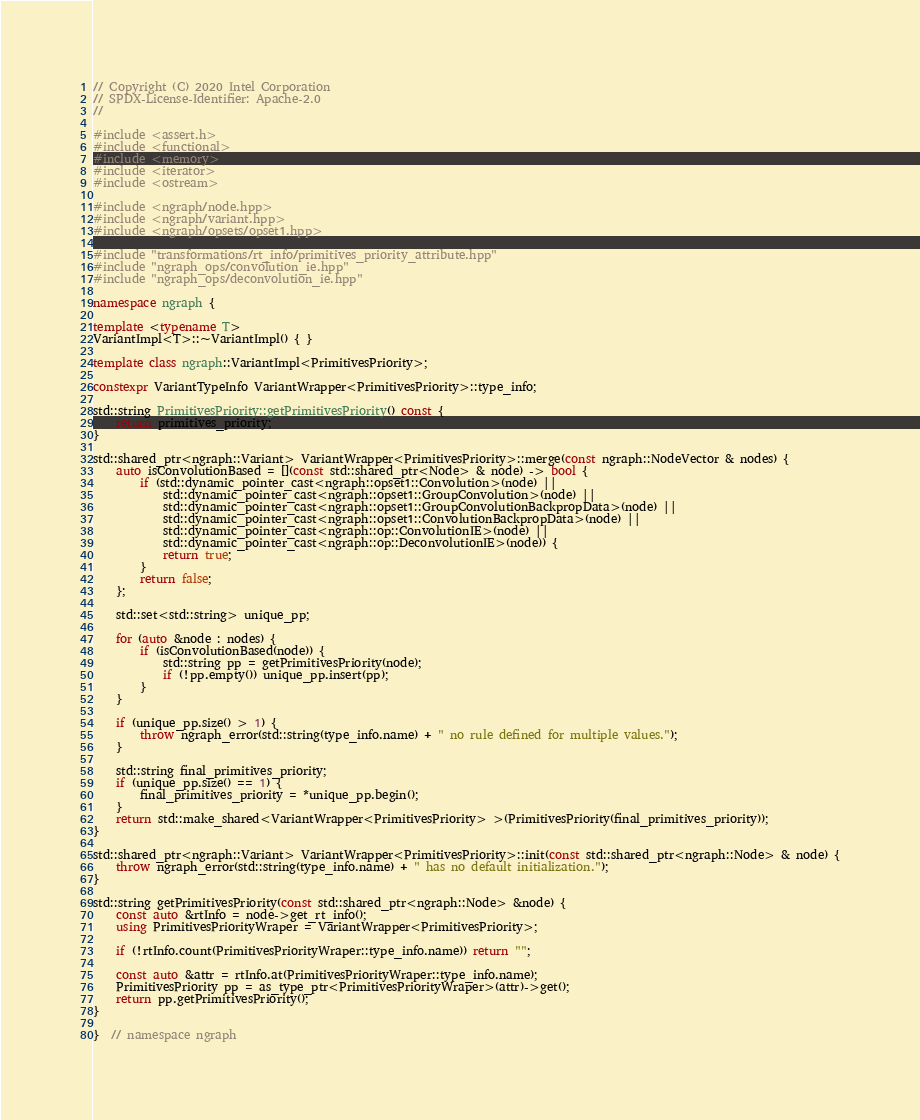Convert code to text. <code><loc_0><loc_0><loc_500><loc_500><_C++_>// Copyright (C) 2020 Intel Corporation
// SPDX-License-Identifier: Apache-2.0
//

#include <assert.h>
#include <functional>
#include <memory>
#include <iterator>
#include <ostream>

#include <ngraph/node.hpp>
#include <ngraph/variant.hpp>
#include <ngraph/opsets/opset1.hpp>

#include "transformations/rt_info/primitives_priority_attribute.hpp"
#include "ngraph_ops/convolution_ie.hpp"
#include "ngraph_ops/deconvolution_ie.hpp"

namespace ngraph {

template <typename T>
VariantImpl<T>::~VariantImpl() { }

template class ngraph::VariantImpl<PrimitivesPriority>;

constexpr VariantTypeInfo VariantWrapper<PrimitivesPriority>::type_info;

std::string PrimitivesPriority::getPrimitivesPriority() const {
    return primitives_priority;
}

std::shared_ptr<ngraph::Variant> VariantWrapper<PrimitivesPriority>::merge(const ngraph::NodeVector & nodes) {
    auto isConvolutionBased = [](const std::shared_ptr<Node> & node) -> bool {
        if (std::dynamic_pointer_cast<ngraph::opset1::Convolution>(node) ||
            std::dynamic_pointer_cast<ngraph::opset1::GroupConvolution>(node) ||
            std::dynamic_pointer_cast<ngraph::opset1::GroupConvolutionBackpropData>(node) ||
            std::dynamic_pointer_cast<ngraph::opset1::ConvolutionBackpropData>(node) ||
            std::dynamic_pointer_cast<ngraph::op::ConvolutionIE>(node) ||
            std::dynamic_pointer_cast<ngraph::op::DeconvolutionIE>(node)) {
            return true;
        }
        return false;
    };

    std::set<std::string> unique_pp;

    for (auto &node : nodes) {
        if (isConvolutionBased(node)) {
            std::string pp = getPrimitivesPriority(node);
            if (!pp.empty()) unique_pp.insert(pp);
        }
    }

    if (unique_pp.size() > 1) {
        throw ngraph_error(std::string(type_info.name) + " no rule defined for multiple values.");
    }

    std::string final_primitives_priority;
    if (unique_pp.size() == 1) {
        final_primitives_priority = *unique_pp.begin();
    }
    return std::make_shared<VariantWrapper<PrimitivesPriority> >(PrimitivesPriority(final_primitives_priority));
}

std::shared_ptr<ngraph::Variant> VariantWrapper<PrimitivesPriority>::init(const std::shared_ptr<ngraph::Node> & node) {
    throw ngraph_error(std::string(type_info.name) + " has no default initialization.");
}

std::string getPrimitivesPriority(const std::shared_ptr<ngraph::Node> &node) {
    const auto &rtInfo = node->get_rt_info();
    using PrimitivesPriorityWraper = VariantWrapper<PrimitivesPriority>;

    if (!rtInfo.count(PrimitivesPriorityWraper::type_info.name)) return "";

    const auto &attr = rtInfo.at(PrimitivesPriorityWraper::type_info.name);
    PrimitivesPriority pp = as_type_ptr<PrimitivesPriorityWraper>(attr)->get();
    return pp.getPrimitivesPriority();
}

}  // namespace ngraph
</code> 